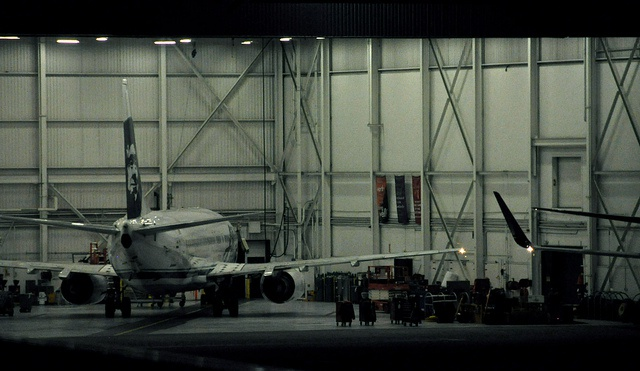Describe the objects in this image and their specific colors. I can see a airplane in black, gray, and darkgray tones in this image. 